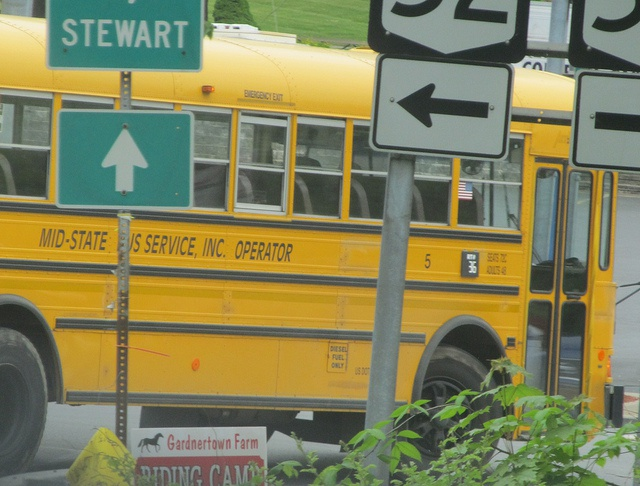Describe the objects in this image and their specific colors. I can see bus in gray, orange, olive, and darkgray tones, chair in gray and black tones, chair in gray and black tones, chair in gray and black tones, and chair in gray, darkgreen, and darkgray tones in this image. 